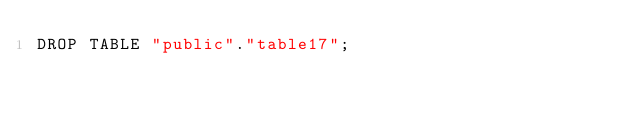<code> <loc_0><loc_0><loc_500><loc_500><_SQL_>DROP TABLE "public"."table17";
</code> 